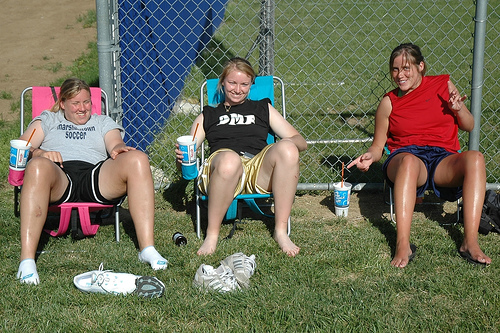<image>
Is there a chair under the lady? Yes. The chair is positioned underneath the lady, with the lady above it in the vertical space. Is the cup next to the fence? Yes. The cup is positioned adjacent to the fence, located nearby in the same general area. 